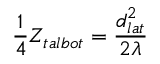<formula> <loc_0><loc_0><loc_500><loc_500>\frac { 1 } { 4 } Z _ { t a l b o t } = \frac { d _ { l a t } ^ { 2 } } { 2 \lambda }</formula> 